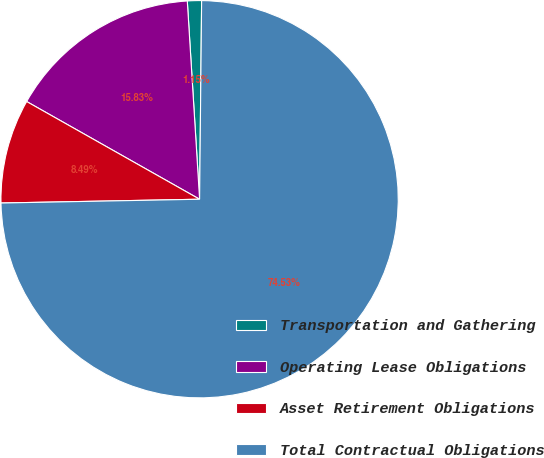Convert chart. <chart><loc_0><loc_0><loc_500><loc_500><pie_chart><fcel>Transportation and Gathering<fcel>Operating Lease Obligations<fcel>Asset Retirement Obligations<fcel>Total Contractual Obligations<nl><fcel>1.15%<fcel>15.83%<fcel>8.49%<fcel>74.54%<nl></chart> 